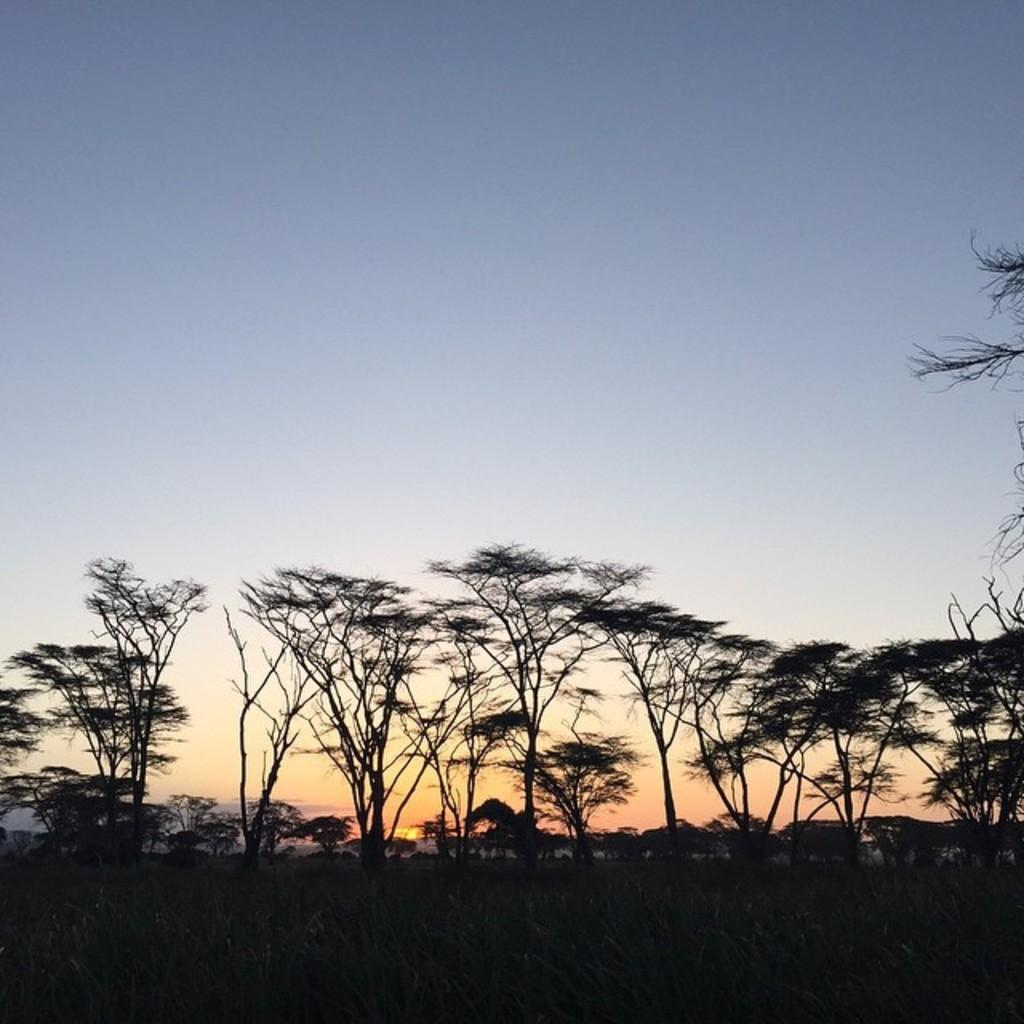What type of natural environment is depicted in the image? The image contains a beautiful view of the forest. What can be seen in the background of the image? There are many trees in the background of the image. What type of mint can be seen growing in the forest in the image? There is no mint visible in the image, as it only depicts a view of the forest with many trees in the background. 